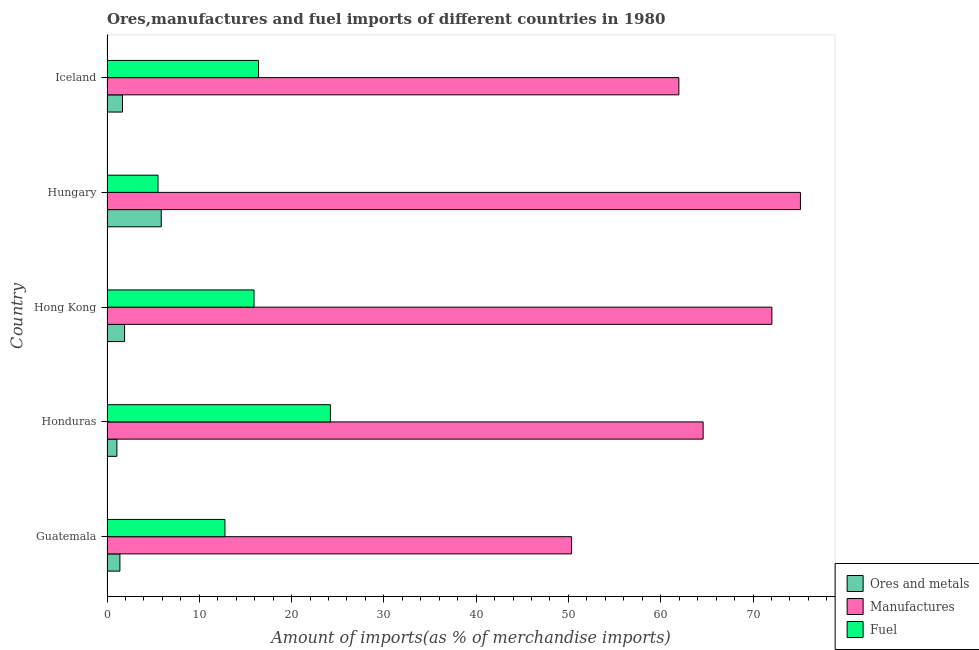How many different coloured bars are there?
Keep it short and to the point. 3. How many groups of bars are there?
Provide a succinct answer. 5. Are the number of bars per tick equal to the number of legend labels?
Make the answer very short. Yes. In how many cases, is the number of bars for a given country not equal to the number of legend labels?
Provide a succinct answer. 0. What is the percentage of ores and metals imports in Honduras?
Give a very brief answer. 1.07. Across all countries, what is the maximum percentage of fuel imports?
Your answer should be very brief. 24.21. Across all countries, what is the minimum percentage of fuel imports?
Ensure brevity in your answer.  5.52. In which country was the percentage of ores and metals imports maximum?
Offer a terse response. Hungary. In which country was the percentage of fuel imports minimum?
Make the answer very short. Hungary. What is the total percentage of ores and metals imports in the graph?
Ensure brevity in your answer.  11.93. What is the difference between the percentage of ores and metals imports in Hong Kong and that in Hungary?
Your answer should be very brief. -3.97. What is the difference between the percentage of fuel imports in Guatemala and the percentage of ores and metals imports in Honduras?
Ensure brevity in your answer.  11.71. What is the average percentage of fuel imports per country?
Provide a short and direct response. 14.97. What is the difference between the percentage of ores and metals imports and percentage of manufactures imports in Hong Kong?
Your response must be concise. -70.14. What is the ratio of the percentage of fuel imports in Hungary to that in Iceland?
Provide a short and direct response. 0.34. What is the difference between the highest and the second highest percentage of manufactures imports?
Give a very brief answer. 3.09. What is the difference between the highest and the lowest percentage of fuel imports?
Your response must be concise. 18.68. What does the 2nd bar from the top in Hong Kong represents?
Provide a succinct answer. Manufactures. What does the 1st bar from the bottom in Iceland represents?
Offer a very short reply. Ores and metals. Is it the case that in every country, the sum of the percentage of ores and metals imports and percentage of manufactures imports is greater than the percentage of fuel imports?
Your answer should be compact. Yes. How many countries are there in the graph?
Your answer should be very brief. 5. Are the values on the major ticks of X-axis written in scientific E-notation?
Provide a short and direct response. No. Does the graph contain grids?
Give a very brief answer. No. Where does the legend appear in the graph?
Keep it short and to the point. Bottom right. How many legend labels are there?
Give a very brief answer. 3. What is the title of the graph?
Offer a terse response. Ores,manufactures and fuel imports of different countries in 1980. What is the label or title of the X-axis?
Keep it short and to the point. Amount of imports(as % of merchandise imports). What is the Amount of imports(as % of merchandise imports) of Ores and metals in Guatemala?
Your answer should be compact. 1.4. What is the Amount of imports(as % of merchandise imports) of Manufactures in Guatemala?
Give a very brief answer. 50.34. What is the Amount of imports(as % of merchandise imports) of Fuel in Guatemala?
Offer a very short reply. 12.78. What is the Amount of imports(as % of merchandise imports) of Ores and metals in Honduras?
Provide a short and direct response. 1.07. What is the Amount of imports(as % of merchandise imports) in Manufactures in Honduras?
Your answer should be very brief. 64.59. What is the Amount of imports(as % of merchandise imports) of Fuel in Honduras?
Ensure brevity in your answer.  24.21. What is the Amount of imports(as % of merchandise imports) in Ores and metals in Hong Kong?
Provide a succinct answer. 1.9. What is the Amount of imports(as % of merchandise imports) of Manufactures in Hong Kong?
Make the answer very short. 72.04. What is the Amount of imports(as % of merchandise imports) in Fuel in Hong Kong?
Give a very brief answer. 15.93. What is the Amount of imports(as % of merchandise imports) of Ores and metals in Hungary?
Offer a very short reply. 5.88. What is the Amount of imports(as % of merchandise imports) in Manufactures in Hungary?
Keep it short and to the point. 75.14. What is the Amount of imports(as % of merchandise imports) of Fuel in Hungary?
Provide a succinct answer. 5.52. What is the Amount of imports(as % of merchandise imports) of Ores and metals in Iceland?
Give a very brief answer. 1.68. What is the Amount of imports(as % of merchandise imports) in Manufactures in Iceland?
Make the answer very short. 61.96. What is the Amount of imports(as % of merchandise imports) of Fuel in Iceland?
Keep it short and to the point. 16.42. Across all countries, what is the maximum Amount of imports(as % of merchandise imports) in Ores and metals?
Your answer should be compact. 5.88. Across all countries, what is the maximum Amount of imports(as % of merchandise imports) of Manufactures?
Make the answer very short. 75.14. Across all countries, what is the maximum Amount of imports(as % of merchandise imports) in Fuel?
Your response must be concise. 24.21. Across all countries, what is the minimum Amount of imports(as % of merchandise imports) of Ores and metals?
Offer a terse response. 1.07. Across all countries, what is the minimum Amount of imports(as % of merchandise imports) in Manufactures?
Your answer should be very brief. 50.34. Across all countries, what is the minimum Amount of imports(as % of merchandise imports) in Fuel?
Provide a succinct answer. 5.52. What is the total Amount of imports(as % of merchandise imports) of Ores and metals in the graph?
Provide a succinct answer. 11.93. What is the total Amount of imports(as % of merchandise imports) in Manufactures in the graph?
Your response must be concise. 324.07. What is the total Amount of imports(as % of merchandise imports) of Fuel in the graph?
Give a very brief answer. 74.86. What is the difference between the Amount of imports(as % of merchandise imports) in Ores and metals in Guatemala and that in Honduras?
Give a very brief answer. 0.33. What is the difference between the Amount of imports(as % of merchandise imports) of Manufactures in Guatemala and that in Honduras?
Provide a short and direct response. -14.26. What is the difference between the Amount of imports(as % of merchandise imports) of Fuel in Guatemala and that in Honduras?
Offer a terse response. -11.43. What is the difference between the Amount of imports(as % of merchandise imports) of Ores and metals in Guatemala and that in Hong Kong?
Keep it short and to the point. -0.51. What is the difference between the Amount of imports(as % of merchandise imports) in Manufactures in Guatemala and that in Hong Kong?
Offer a very short reply. -21.71. What is the difference between the Amount of imports(as % of merchandise imports) of Fuel in Guatemala and that in Hong Kong?
Your response must be concise. -3.15. What is the difference between the Amount of imports(as % of merchandise imports) in Ores and metals in Guatemala and that in Hungary?
Your answer should be compact. -4.48. What is the difference between the Amount of imports(as % of merchandise imports) of Manufactures in Guatemala and that in Hungary?
Make the answer very short. -24.8. What is the difference between the Amount of imports(as % of merchandise imports) of Fuel in Guatemala and that in Hungary?
Provide a succinct answer. 7.25. What is the difference between the Amount of imports(as % of merchandise imports) in Ores and metals in Guatemala and that in Iceland?
Ensure brevity in your answer.  -0.28. What is the difference between the Amount of imports(as % of merchandise imports) of Manufactures in Guatemala and that in Iceland?
Make the answer very short. -11.62. What is the difference between the Amount of imports(as % of merchandise imports) of Fuel in Guatemala and that in Iceland?
Provide a short and direct response. -3.64. What is the difference between the Amount of imports(as % of merchandise imports) in Ores and metals in Honduras and that in Hong Kong?
Your response must be concise. -0.83. What is the difference between the Amount of imports(as % of merchandise imports) of Manufactures in Honduras and that in Hong Kong?
Ensure brevity in your answer.  -7.45. What is the difference between the Amount of imports(as % of merchandise imports) in Fuel in Honduras and that in Hong Kong?
Offer a terse response. 8.28. What is the difference between the Amount of imports(as % of merchandise imports) in Ores and metals in Honduras and that in Hungary?
Your answer should be compact. -4.81. What is the difference between the Amount of imports(as % of merchandise imports) of Manufactures in Honduras and that in Hungary?
Your answer should be compact. -10.54. What is the difference between the Amount of imports(as % of merchandise imports) in Fuel in Honduras and that in Hungary?
Provide a short and direct response. 18.68. What is the difference between the Amount of imports(as % of merchandise imports) of Ores and metals in Honduras and that in Iceland?
Provide a succinct answer. -0.61. What is the difference between the Amount of imports(as % of merchandise imports) of Manufactures in Honduras and that in Iceland?
Offer a terse response. 2.63. What is the difference between the Amount of imports(as % of merchandise imports) of Fuel in Honduras and that in Iceland?
Give a very brief answer. 7.79. What is the difference between the Amount of imports(as % of merchandise imports) of Ores and metals in Hong Kong and that in Hungary?
Provide a short and direct response. -3.97. What is the difference between the Amount of imports(as % of merchandise imports) in Manufactures in Hong Kong and that in Hungary?
Provide a succinct answer. -3.09. What is the difference between the Amount of imports(as % of merchandise imports) of Fuel in Hong Kong and that in Hungary?
Provide a succinct answer. 10.41. What is the difference between the Amount of imports(as % of merchandise imports) of Ores and metals in Hong Kong and that in Iceland?
Your answer should be very brief. 0.22. What is the difference between the Amount of imports(as % of merchandise imports) of Manufactures in Hong Kong and that in Iceland?
Offer a terse response. 10.08. What is the difference between the Amount of imports(as % of merchandise imports) in Fuel in Hong Kong and that in Iceland?
Provide a succinct answer. -0.49. What is the difference between the Amount of imports(as % of merchandise imports) in Ores and metals in Hungary and that in Iceland?
Your answer should be compact. 4.2. What is the difference between the Amount of imports(as % of merchandise imports) of Manufactures in Hungary and that in Iceland?
Your response must be concise. 13.18. What is the difference between the Amount of imports(as % of merchandise imports) of Fuel in Hungary and that in Iceland?
Your response must be concise. -10.89. What is the difference between the Amount of imports(as % of merchandise imports) in Ores and metals in Guatemala and the Amount of imports(as % of merchandise imports) in Manufactures in Honduras?
Provide a succinct answer. -63.19. What is the difference between the Amount of imports(as % of merchandise imports) in Ores and metals in Guatemala and the Amount of imports(as % of merchandise imports) in Fuel in Honduras?
Provide a short and direct response. -22.81. What is the difference between the Amount of imports(as % of merchandise imports) of Manufactures in Guatemala and the Amount of imports(as % of merchandise imports) of Fuel in Honduras?
Your answer should be very brief. 26.13. What is the difference between the Amount of imports(as % of merchandise imports) of Ores and metals in Guatemala and the Amount of imports(as % of merchandise imports) of Manufactures in Hong Kong?
Ensure brevity in your answer.  -70.65. What is the difference between the Amount of imports(as % of merchandise imports) in Ores and metals in Guatemala and the Amount of imports(as % of merchandise imports) in Fuel in Hong Kong?
Offer a very short reply. -14.53. What is the difference between the Amount of imports(as % of merchandise imports) in Manufactures in Guatemala and the Amount of imports(as % of merchandise imports) in Fuel in Hong Kong?
Keep it short and to the point. 34.41. What is the difference between the Amount of imports(as % of merchandise imports) in Ores and metals in Guatemala and the Amount of imports(as % of merchandise imports) in Manufactures in Hungary?
Your response must be concise. -73.74. What is the difference between the Amount of imports(as % of merchandise imports) of Ores and metals in Guatemala and the Amount of imports(as % of merchandise imports) of Fuel in Hungary?
Make the answer very short. -4.13. What is the difference between the Amount of imports(as % of merchandise imports) in Manufactures in Guatemala and the Amount of imports(as % of merchandise imports) in Fuel in Hungary?
Your response must be concise. 44.81. What is the difference between the Amount of imports(as % of merchandise imports) in Ores and metals in Guatemala and the Amount of imports(as % of merchandise imports) in Manufactures in Iceland?
Offer a terse response. -60.56. What is the difference between the Amount of imports(as % of merchandise imports) in Ores and metals in Guatemala and the Amount of imports(as % of merchandise imports) in Fuel in Iceland?
Offer a very short reply. -15.02. What is the difference between the Amount of imports(as % of merchandise imports) in Manufactures in Guatemala and the Amount of imports(as % of merchandise imports) in Fuel in Iceland?
Offer a terse response. 33.92. What is the difference between the Amount of imports(as % of merchandise imports) in Ores and metals in Honduras and the Amount of imports(as % of merchandise imports) in Manufactures in Hong Kong?
Offer a terse response. -70.97. What is the difference between the Amount of imports(as % of merchandise imports) of Ores and metals in Honduras and the Amount of imports(as % of merchandise imports) of Fuel in Hong Kong?
Your answer should be compact. -14.86. What is the difference between the Amount of imports(as % of merchandise imports) in Manufactures in Honduras and the Amount of imports(as % of merchandise imports) in Fuel in Hong Kong?
Your response must be concise. 48.66. What is the difference between the Amount of imports(as % of merchandise imports) of Ores and metals in Honduras and the Amount of imports(as % of merchandise imports) of Manufactures in Hungary?
Keep it short and to the point. -74.07. What is the difference between the Amount of imports(as % of merchandise imports) of Ores and metals in Honduras and the Amount of imports(as % of merchandise imports) of Fuel in Hungary?
Provide a short and direct response. -4.45. What is the difference between the Amount of imports(as % of merchandise imports) of Manufactures in Honduras and the Amount of imports(as % of merchandise imports) of Fuel in Hungary?
Give a very brief answer. 59.07. What is the difference between the Amount of imports(as % of merchandise imports) of Ores and metals in Honduras and the Amount of imports(as % of merchandise imports) of Manufactures in Iceland?
Your answer should be compact. -60.89. What is the difference between the Amount of imports(as % of merchandise imports) of Ores and metals in Honduras and the Amount of imports(as % of merchandise imports) of Fuel in Iceland?
Make the answer very short. -15.35. What is the difference between the Amount of imports(as % of merchandise imports) of Manufactures in Honduras and the Amount of imports(as % of merchandise imports) of Fuel in Iceland?
Provide a short and direct response. 48.17. What is the difference between the Amount of imports(as % of merchandise imports) in Ores and metals in Hong Kong and the Amount of imports(as % of merchandise imports) in Manufactures in Hungary?
Your response must be concise. -73.23. What is the difference between the Amount of imports(as % of merchandise imports) of Ores and metals in Hong Kong and the Amount of imports(as % of merchandise imports) of Fuel in Hungary?
Provide a succinct answer. -3.62. What is the difference between the Amount of imports(as % of merchandise imports) in Manufactures in Hong Kong and the Amount of imports(as % of merchandise imports) in Fuel in Hungary?
Your answer should be very brief. 66.52. What is the difference between the Amount of imports(as % of merchandise imports) of Ores and metals in Hong Kong and the Amount of imports(as % of merchandise imports) of Manufactures in Iceland?
Keep it short and to the point. -60.06. What is the difference between the Amount of imports(as % of merchandise imports) of Ores and metals in Hong Kong and the Amount of imports(as % of merchandise imports) of Fuel in Iceland?
Your answer should be compact. -14.51. What is the difference between the Amount of imports(as % of merchandise imports) in Manufactures in Hong Kong and the Amount of imports(as % of merchandise imports) in Fuel in Iceland?
Keep it short and to the point. 55.62. What is the difference between the Amount of imports(as % of merchandise imports) of Ores and metals in Hungary and the Amount of imports(as % of merchandise imports) of Manufactures in Iceland?
Provide a succinct answer. -56.08. What is the difference between the Amount of imports(as % of merchandise imports) of Ores and metals in Hungary and the Amount of imports(as % of merchandise imports) of Fuel in Iceland?
Provide a succinct answer. -10.54. What is the difference between the Amount of imports(as % of merchandise imports) in Manufactures in Hungary and the Amount of imports(as % of merchandise imports) in Fuel in Iceland?
Offer a terse response. 58.72. What is the average Amount of imports(as % of merchandise imports) of Ores and metals per country?
Provide a short and direct response. 2.39. What is the average Amount of imports(as % of merchandise imports) in Manufactures per country?
Provide a short and direct response. 64.81. What is the average Amount of imports(as % of merchandise imports) of Fuel per country?
Offer a terse response. 14.97. What is the difference between the Amount of imports(as % of merchandise imports) in Ores and metals and Amount of imports(as % of merchandise imports) in Manufactures in Guatemala?
Keep it short and to the point. -48.94. What is the difference between the Amount of imports(as % of merchandise imports) of Ores and metals and Amount of imports(as % of merchandise imports) of Fuel in Guatemala?
Offer a very short reply. -11.38. What is the difference between the Amount of imports(as % of merchandise imports) of Manufactures and Amount of imports(as % of merchandise imports) of Fuel in Guatemala?
Your response must be concise. 37.56. What is the difference between the Amount of imports(as % of merchandise imports) of Ores and metals and Amount of imports(as % of merchandise imports) of Manufactures in Honduras?
Offer a terse response. -63.52. What is the difference between the Amount of imports(as % of merchandise imports) of Ores and metals and Amount of imports(as % of merchandise imports) of Fuel in Honduras?
Ensure brevity in your answer.  -23.14. What is the difference between the Amount of imports(as % of merchandise imports) of Manufactures and Amount of imports(as % of merchandise imports) of Fuel in Honduras?
Provide a succinct answer. 40.39. What is the difference between the Amount of imports(as % of merchandise imports) of Ores and metals and Amount of imports(as % of merchandise imports) of Manufactures in Hong Kong?
Your answer should be very brief. -70.14. What is the difference between the Amount of imports(as % of merchandise imports) in Ores and metals and Amount of imports(as % of merchandise imports) in Fuel in Hong Kong?
Make the answer very short. -14.03. What is the difference between the Amount of imports(as % of merchandise imports) in Manufactures and Amount of imports(as % of merchandise imports) in Fuel in Hong Kong?
Offer a terse response. 56.11. What is the difference between the Amount of imports(as % of merchandise imports) of Ores and metals and Amount of imports(as % of merchandise imports) of Manufactures in Hungary?
Ensure brevity in your answer.  -69.26. What is the difference between the Amount of imports(as % of merchandise imports) in Ores and metals and Amount of imports(as % of merchandise imports) in Fuel in Hungary?
Your answer should be compact. 0.35. What is the difference between the Amount of imports(as % of merchandise imports) in Manufactures and Amount of imports(as % of merchandise imports) in Fuel in Hungary?
Your answer should be compact. 69.61. What is the difference between the Amount of imports(as % of merchandise imports) in Ores and metals and Amount of imports(as % of merchandise imports) in Manufactures in Iceland?
Offer a terse response. -60.28. What is the difference between the Amount of imports(as % of merchandise imports) in Ores and metals and Amount of imports(as % of merchandise imports) in Fuel in Iceland?
Your answer should be very brief. -14.74. What is the difference between the Amount of imports(as % of merchandise imports) of Manufactures and Amount of imports(as % of merchandise imports) of Fuel in Iceland?
Make the answer very short. 45.54. What is the ratio of the Amount of imports(as % of merchandise imports) of Ores and metals in Guatemala to that in Honduras?
Keep it short and to the point. 1.31. What is the ratio of the Amount of imports(as % of merchandise imports) of Manufactures in Guatemala to that in Honduras?
Keep it short and to the point. 0.78. What is the ratio of the Amount of imports(as % of merchandise imports) in Fuel in Guatemala to that in Honduras?
Provide a succinct answer. 0.53. What is the ratio of the Amount of imports(as % of merchandise imports) in Ores and metals in Guatemala to that in Hong Kong?
Give a very brief answer. 0.73. What is the ratio of the Amount of imports(as % of merchandise imports) in Manufactures in Guatemala to that in Hong Kong?
Make the answer very short. 0.7. What is the ratio of the Amount of imports(as % of merchandise imports) in Fuel in Guatemala to that in Hong Kong?
Offer a very short reply. 0.8. What is the ratio of the Amount of imports(as % of merchandise imports) in Ores and metals in Guatemala to that in Hungary?
Offer a terse response. 0.24. What is the ratio of the Amount of imports(as % of merchandise imports) in Manufactures in Guatemala to that in Hungary?
Offer a terse response. 0.67. What is the ratio of the Amount of imports(as % of merchandise imports) of Fuel in Guatemala to that in Hungary?
Give a very brief answer. 2.31. What is the ratio of the Amount of imports(as % of merchandise imports) in Ores and metals in Guatemala to that in Iceland?
Make the answer very short. 0.83. What is the ratio of the Amount of imports(as % of merchandise imports) in Manufactures in Guatemala to that in Iceland?
Keep it short and to the point. 0.81. What is the ratio of the Amount of imports(as % of merchandise imports) in Fuel in Guatemala to that in Iceland?
Your answer should be compact. 0.78. What is the ratio of the Amount of imports(as % of merchandise imports) of Ores and metals in Honduras to that in Hong Kong?
Offer a terse response. 0.56. What is the ratio of the Amount of imports(as % of merchandise imports) of Manufactures in Honduras to that in Hong Kong?
Give a very brief answer. 0.9. What is the ratio of the Amount of imports(as % of merchandise imports) of Fuel in Honduras to that in Hong Kong?
Provide a succinct answer. 1.52. What is the ratio of the Amount of imports(as % of merchandise imports) of Ores and metals in Honduras to that in Hungary?
Your answer should be very brief. 0.18. What is the ratio of the Amount of imports(as % of merchandise imports) of Manufactures in Honduras to that in Hungary?
Provide a succinct answer. 0.86. What is the ratio of the Amount of imports(as % of merchandise imports) in Fuel in Honduras to that in Hungary?
Offer a terse response. 4.38. What is the ratio of the Amount of imports(as % of merchandise imports) of Ores and metals in Honduras to that in Iceland?
Offer a terse response. 0.64. What is the ratio of the Amount of imports(as % of merchandise imports) of Manufactures in Honduras to that in Iceland?
Your answer should be compact. 1.04. What is the ratio of the Amount of imports(as % of merchandise imports) of Fuel in Honduras to that in Iceland?
Offer a terse response. 1.47. What is the ratio of the Amount of imports(as % of merchandise imports) in Ores and metals in Hong Kong to that in Hungary?
Keep it short and to the point. 0.32. What is the ratio of the Amount of imports(as % of merchandise imports) of Manufactures in Hong Kong to that in Hungary?
Offer a very short reply. 0.96. What is the ratio of the Amount of imports(as % of merchandise imports) in Fuel in Hong Kong to that in Hungary?
Make the answer very short. 2.88. What is the ratio of the Amount of imports(as % of merchandise imports) in Ores and metals in Hong Kong to that in Iceland?
Give a very brief answer. 1.13. What is the ratio of the Amount of imports(as % of merchandise imports) in Manufactures in Hong Kong to that in Iceland?
Your response must be concise. 1.16. What is the ratio of the Amount of imports(as % of merchandise imports) in Fuel in Hong Kong to that in Iceland?
Offer a very short reply. 0.97. What is the ratio of the Amount of imports(as % of merchandise imports) of Ores and metals in Hungary to that in Iceland?
Your answer should be compact. 3.5. What is the ratio of the Amount of imports(as % of merchandise imports) in Manufactures in Hungary to that in Iceland?
Keep it short and to the point. 1.21. What is the ratio of the Amount of imports(as % of merchandise imports) in Fuel in Hungary to that in Iceland?
Your answer should be very brief. 0.34. What is the difference between the highest and the second highest Amount of imports(as % of merchandise imports) in Ores and metals?
Your answer should be compact. 3.97. What is the difference between the highest and the second highest Amount of imports(as % of merchandise imports) in Manufactures?
Keep it short and to the point. 3.09. What is the difference between the highest and the second highest Amount of imports(as % of merchandise imports) in Fuel?
Offer a terse response. 7.79. What is the difference between the highest and the lowest Amount of imports(as % of merchandise imports) of Ores and metals?
Keep it short and to the point. 4.81. What is the difference between the highest and the lowest Amount of imports(as % of merchandise imports) of Manufactures?
Provide a short and direct response. 24.8. What is the difference between the highest and the lowest Amount of imports(as % of merchandise imports) of Fuel?
Offer a very short reply. 18.68. 